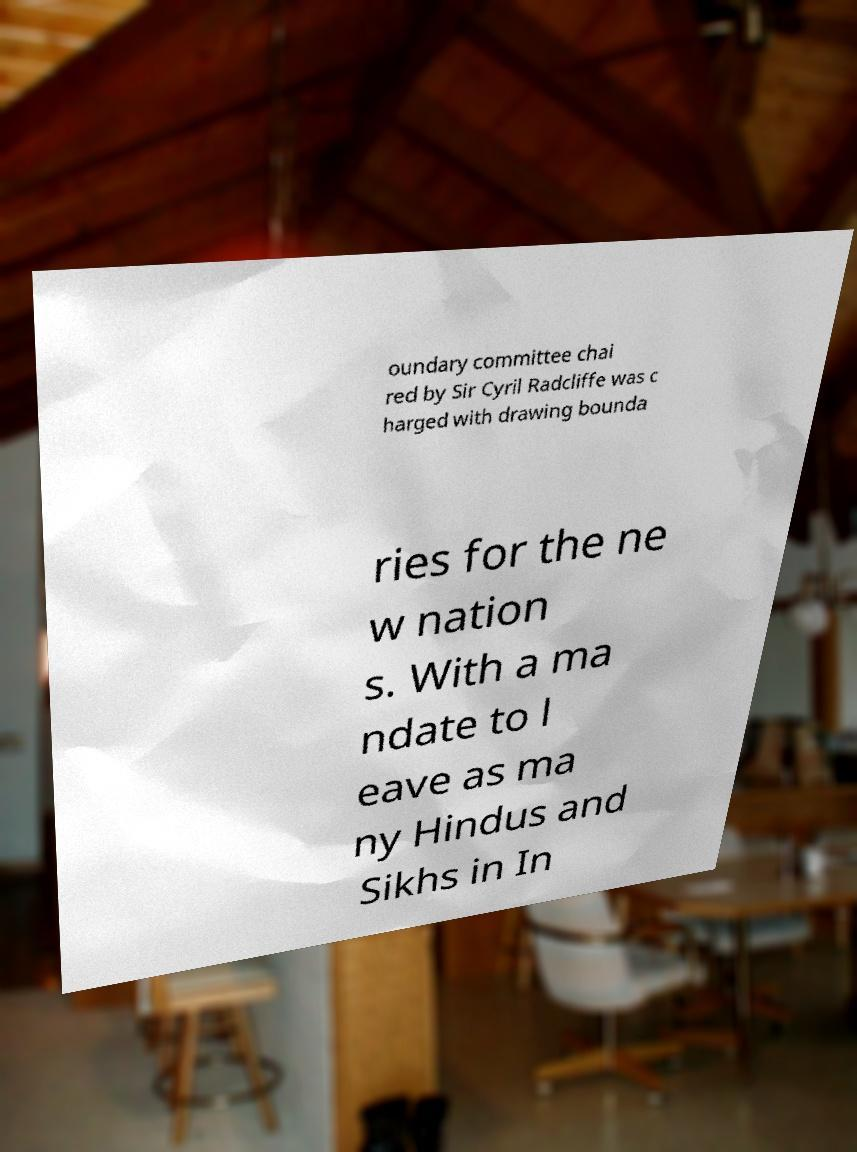Can you read and provide the text displayed in the image?This photo seems to have some interesting text. Can you extract and type it out for me? oundary committee chai red by Sir Cyril Radcliffe was c harged with drawing bounda ries for the ne w nation s. With a ma ndate to l eave as ma ny Hindus and Sikhs in In 